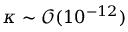<formula> <loc_0><loc_0><loc_500><loc_500>\kappa \sim \mathcal { O } ( 1 0 ^ { - 1 2 } )</formula> 